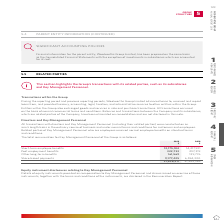According to Woolworths Limited's financial document, What is the amount of short-term employee benefits in 2018? According to the financial document, 14,217,931. The relevant text states: "Short-term employee benefits 12,175,184 14,217,931 Post employment benefits 322,733 297,319 Other long-term benefits 161,569 139,776 Share-based payme..." Also, What is the total remuneration for Key Management Personnel of the Group in 2019? According to the financial document, 21,836,911. The relevant text states: "139,776 Share-based payments 9,177,425 6,594,300 21,836,911 21,249,326..." Also, How were transactions conducted? on an arm’s length basis in the ordinary course of business and under normal terms and conditions for customers and employees.. The document states: "l (including their related parties) were conducted on an arm’s length basis in the ordinary course of business and under normal terms and conditions f..." Also, can you calculate: What is the difference in short-term employee benefits between 2018 and 2019? Based on the calculation: 14,217,931 - 12,175,184 , the result is 2042747. This is based on the information: "Short-term employee benefits 12,175,184 14,217,931 Post employment benefits 322,733 297,319 Other long-term benefits 161,569 139,776 Share-based payme Short-term employee benefits 12,175,184 14,217,93..." The key data points involved are: 12,175,184, 14,217,931. Also, can you calculate: What is the average post employment benefits for 2018 and 2019? To answer this question, I need to perform calculations using the financial data. The calculation is: (322,733 + 297,319)/2 , which equals 310026. This is based on the information: "ts 12,175,184 14,217,931 Post employment benefits 322,733 297,319 Other long-term benefits 161,569 139,776 Share-based payments 9,177,425 6,594,300 21,836,91 5,184 14,217,931 Post employment benefits ..." The key data points involved are: 297,319, 322,733. Also, can you calculate: What is the difference in the total remuneration for Key Management Personnel of the Group between 2018 and 2019? Based on the calculation: 21,836,911 - 21,249,326 , the result is 587585. This is based on the information: "are-based payments 9,177,425 6,594,300 21,836,911 21,249,326 139,776 Share-based payments 9,177,425 6,594,300 21,836,911 21,249,326..." The key data points involved are: 21,249,326, 21,836,911. 